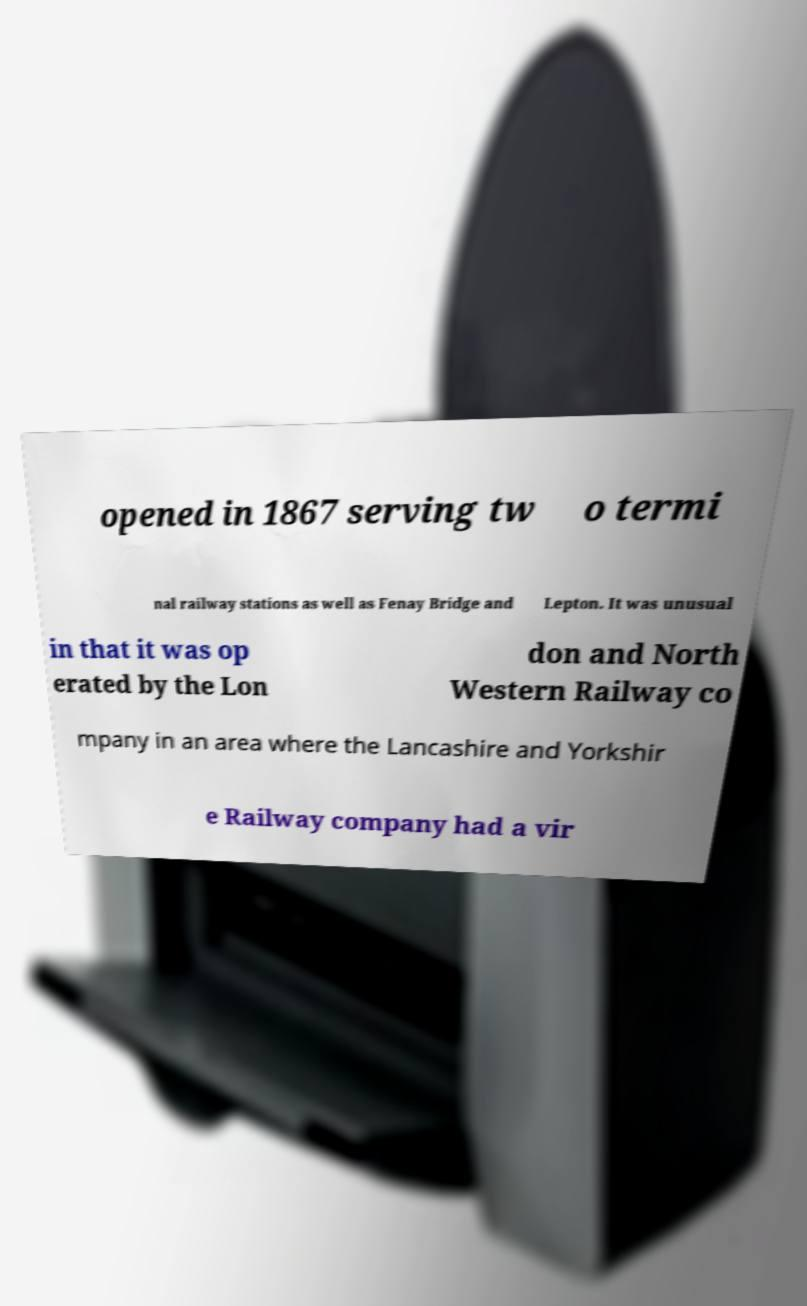There's text embedded in this image that I need extracted. Can you transcribe it verbatim? opened in 1867 serving tw o termi nal railway stations as well as Fenay Bridge and Lepton. It was unusual in that it was op erated by the Lon don and North Western Railway co mpany in an area where the Lancashire and Yorkshir e Railway company had a vir 